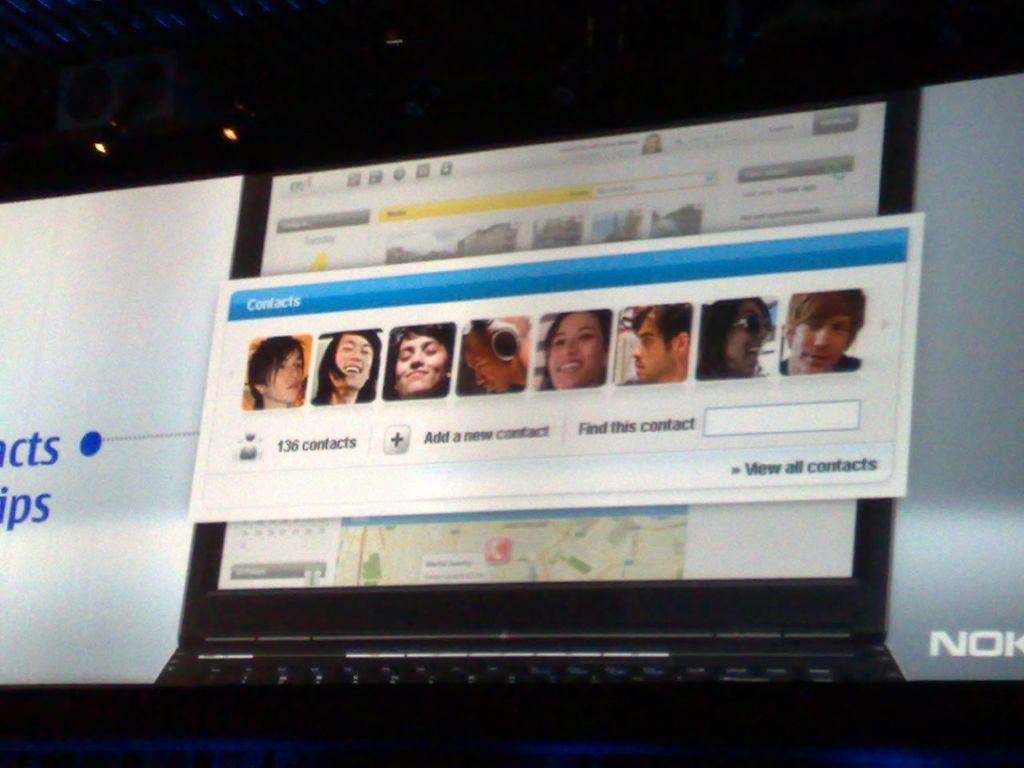<image>
Summarize the visual content of the image. The view all contacts option can be seen below several pictures of people. 